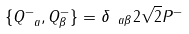Convert formula to latex. <formula><loc_0><loc_0><loc_500><loc_500>\{ Q ^ { - } _ { \ a } , Q ^ { - } _ { \beta } \} = \delta _ { \ a \beta } 2 \sqrt { 2 } P ^ { - }</formula> 